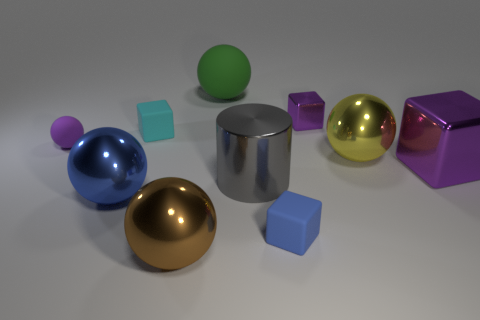How many objects are there in the image, and can you describe their shapes? The image contains a total of nine objects, featuring a variety of shapes: there are three spheres, one cylinder, and five cubes. The objects are spread across the surface in an aesthetically pleasing arrangement.  Do the objects share a common color palette or theme? Yes, the objects share a coherent color palette, consisting of vibrant primary and secondary colors - blue, green, purple, and yellow - alongside metallic hues like silver and gold, which together create a visually harmonious scene. 